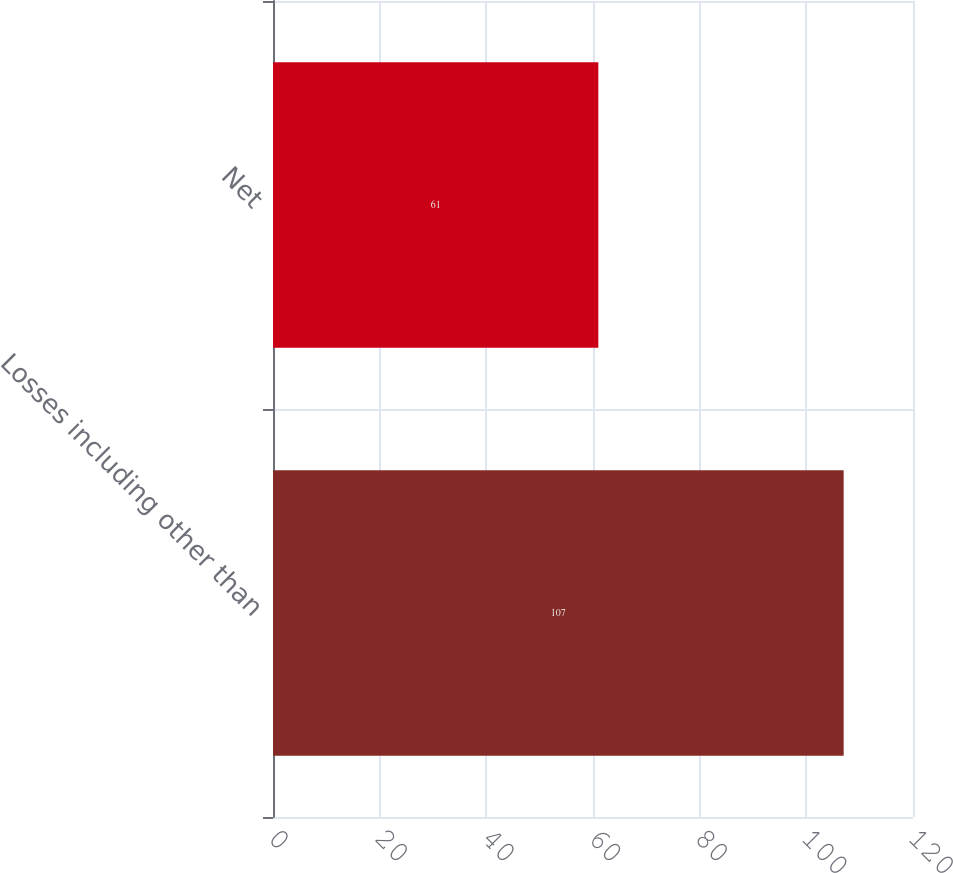<chart> <loc_0><loc_0><loc_500><loc_500><bar_chart><fcel>Losses including other than<fcel>Net<nl><fcel>107<fcel>61<nl></chart> 